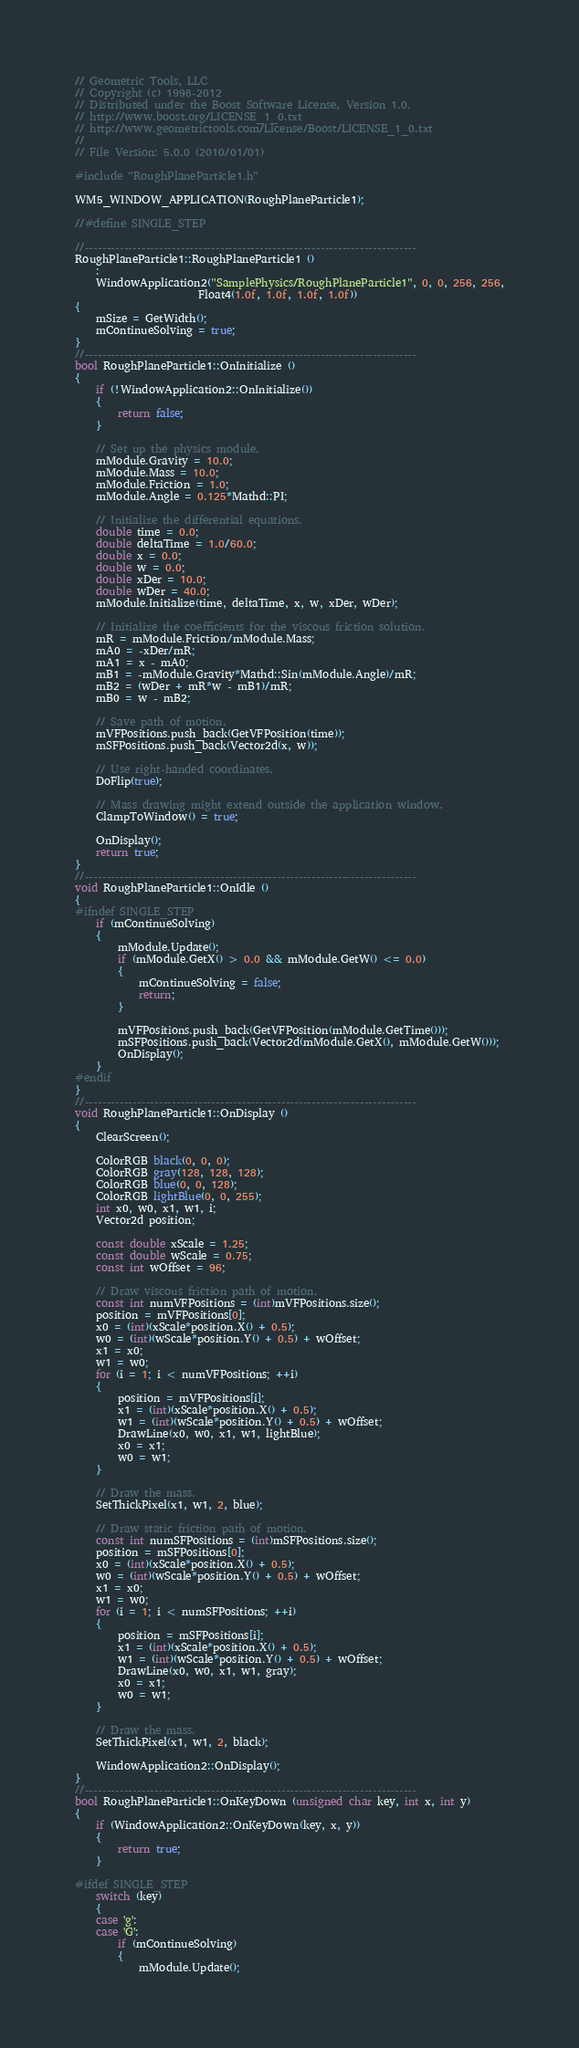Convert code to text. <code><loc_0><loc_0><loc_500><loc_500><_C++_>// Geometric Tools, LLC
// Copyright (c) 1998-2012
// Distributed under the Boost Software License, Version 1.0.
// http://www.boost.org/LICENSE_1_0.txt
// http://www.geometrictools.com/License/Boost/LICENSE_1_0.txt
//
// File Version: 5.0.0 (2010/01/01)

#include "RoughPlaneParticle1.h"

WM5_WINDOW_APPLICATION(RoughPlaneParticle1);

//#define SINGLE_STEP

//----------------------------------------------------------------------------
RoughPlaneParticle1::RoughPlaneParticle1 ()
	:
	WindowApplication2("SamplePhysics/RoughPlaneParticle1", 0, 0, 256, 256,
	                   Float4(1.0f, 1.0f, 1.0f, 1.0f))
{
	mSize = GetWidth();
	mContinueSolving = true;
}
//----------------------------------------------------------------------------
bool RoughPlaneParticle1::OnInitialize ()
{
	if (!WindowApplication2::OnInitialize())
	{
		return false;
	}

	// Set up the physics module.
	mModule.Gravity = 10.0;
	mModule.Mass = 10.0;
	mModule.Friction = 1.0;
	mModule.Angle = 0.125*Mathd::PI;

	// Initialize the differential equations.
	double time = 0.0;
	double deltaTime = 1.0/60.0;
	double x = 0.0;
	double w = 0.0;
	double xDer = 10.0;
	double wDer = 40.0;
	mModule.Initialize(time, deltaTime, x, w, xDer, wDer);

	// Initialize the coefficients for the viscous friction solution.
	mR = mModule.Friction/mModule.Mass;
	mA0 = -xDer/mR;
	mA1 = x - mA0;
	mB1 = -mModule.Gravity*Mathd::Sin(mModule.Angle)/mR;
	mB2 = (wDer + mR*w - mB1)/mR;
	mB0 = w - mB2;

	// Save path of motion.
	mVFPositions.push_back(GetVFPosition(time));
	mSFPositions.push_back(Vector2d(x, w));

	// Use right-handed coordinates.
	DoFlip(true);

	// Mass drawing might extend outside the application window.
	ClampToWindow() = true;

	OnDisplay();
	return true;
}
//----------------------------------------------------------------------------
void RoughPlaneParticle1::OnIdle ()
{
#ifndef SINGLE_STEP
	if (mContinueSolving)
	{
		mModule.Update();
		if (mModule.GetX() > 0.0 && mModule.GetW() <= 0.0)
		{
			mContinueSolving = false;
			return;
		}

		mVFPositions.push_back(GetVFPosition(mModule.GetTime()));
		mSFPositions.push_back(Vector2d(mModule.GetX(), mModule.GetW()));
		OnDisplay();
	}
#endif
}
//----------------------------------------------------------------------------
void RoughPlaneParticle1::OnDisplay ()
{
	ClearScreen();

	ColorRGB black(0, 0, 0);
	ColorRGB gray(128, 128, 128);
	ColorRGB blue(0, 0, 128);
	ColorRGB lightBlue(0, 0, 255);
	int x0, w0, x1, w1, i;
	Vector2d position;

	const double xScale = 1.25;
	const double wScale = 0.75;
	const int wOffset = 96;

	// Draw viscous friction path of motion.
	const int numVFPositions = (int)mVFPositions.size();
	position = mVFPositions[0];
	x0 = (int)(xScale*position.X() + 0.5);
	w0 = (int)(wScale*position.Y() + 0.5) + wOffset;
	x1 = x0;
	w1 = w0;
	for (i = 1; i < numVFPositions; ++i)
	{
		position = mVFPositions[i];
		x1 = (int)(xScale*position.X() + 0.5);
		w1 = (int)(wScale*position.Y() + 0.5) + wOffset;
		DrawLine(x0, w0, x1, w1, lightBlue);
		x0 = x1;
		w0 = w1;
	}

	// Draw the mass.
	SetThickPixel(x1, w1, 2, blue);

	// Draw static friction path of motion.
	const int numSFPositions = (int)mSFPositions.size();
	position = mSFPositions[0];
	x0 = (int)(xScale*position.X() + 0.5);
	w0 = (int)(wScale*position.Y() + 0.5) + wOffset;
	x1 = x0;
	w1 = w0;
	for (i = 1; i < numSFPositions; ++i)
	{
		position = mSFPositions[i];
		x1 = (int)(xScale*position.X() + 0.5);
		w1 = (int)(wScale*position.Y() + 0.5) + wOffset;
		DrawLine(x0, w0, x1, w1, gray);
		x0 = x1;
		w0 = w1;
	}

	// Draw the mass.
	SetThickPixel(x1, w1, 2, black);

	WindowApplication2::OnDisplay();
}
//----------------------------------------------------------------------------
bool RoughPlaneParticle1::OnKeyDown (unsigned char key, int x, int y)
{
	if (WindowApplication2::OnKeyDown(key, x, y))
	{
		return true;
	}

#ifdef SINGLE_STEP
	switch (key)
	{
	case 'g':
	case 'G':
		if (mContinueSolving)
		{
			mModule.Update();</code> 